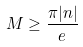<formula> <loc_0><loc_0><loc_500><loc_500>M \geq \frac { \pi | n | } { e }</formula> 